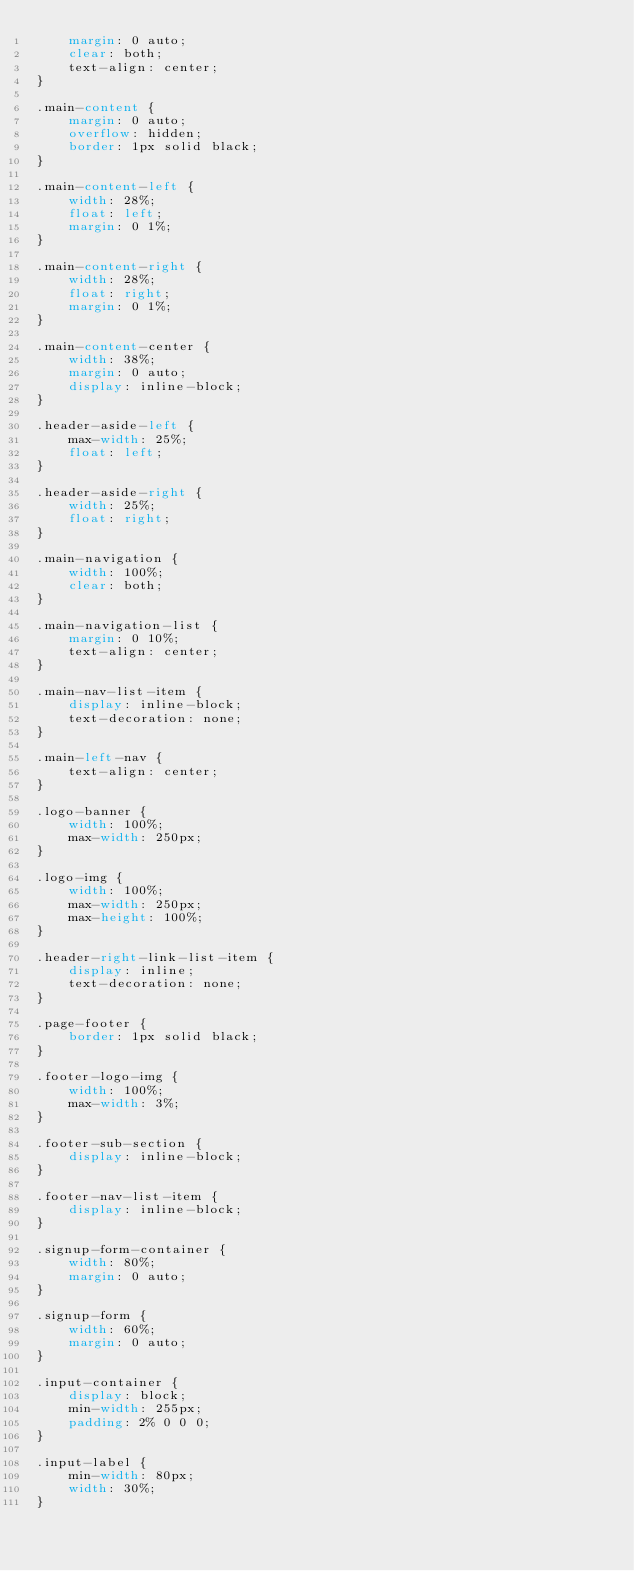Convert code to text. <code><loc_0><loc_0><loc_500><loc_500><_CSS_>    margin: 0 auto;
    clear: both;
    text-align: center;
}

.main-content {
    margin: 0 auto;
    overflow: hidden;
    border: 1px solid black;
}

.main-content-left {
    width: 28%;
    float: left;
    margin: 0 1%;
}

.main-content-right {
    width: 28%;
    float: right;
    margin: 0 1%;
}

.main-content-center {
    width: 38%;
    margin: 0 auto;
    display: inline-block;
}

.header-aside-left {
    max-width: 25%;
    float: left;
}

.header-aside-right {
    width: 25%;
    float: right;
}

.main-navigation {
    width: 100%;
    clear: both;
}

.main-navigation-list {
    margin: 0 10%;
    text-align: center;
}

.main-nav-list-item {
    display: inline-block;
    text-decoration: none;
}

.main-left-nav {
    text-align: center;
}

.logo-banner {
    width: 100%;
    max-width: 250px;
}

.logo-img {
    width: 100%;
    max-width: 250px;
    max-height: 100%;
}

.header-right-link-list-item {
    display: inline;
    text-decoration: none;
}

.page-footer {
    border: 1px solid black;
}

.footer-logo-img {
    width: 100%;
    max-width: 3%;
}

.footer-sub-section {
    display: inline-block;
}

.footer-nav-list-item {
    display: inline-block;
}

.signup-form-container {
    width: 80%;
    margin: 0 auto;
}

.signup-form {
    width: 60%;
    margin: 0 auto;
}

.input-container {
    display: block;
    min-width: 255px;
    padding: 2% 0 0 0;
}

.input-label {
    min-width: 80px;
    width: 30%;
}</code> 